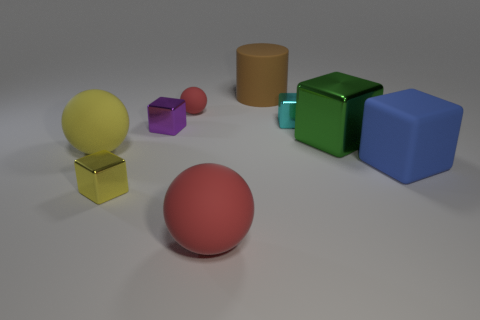How does the composition of shapes and colors contribute to the overall aesthetic of the scene? The composition in the image is thoughtfully arranged with a variety of geometric shapes and a spectrum of colors that balance well against the neutral background. The contrasting colors attract the eye while the differing shapes provide a sense of depth and perspective, collectively contributing to a harmonious and visually pleasing arrangement. 